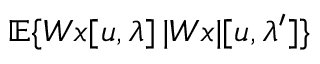<formula> <loc_0><loc_0><loc_500><loc_500>{ \mathbb { E } } \{ W x [ u , \lambda ] \, | W x | [ u , \lambda ^ { \prime } ] \}</formula> 